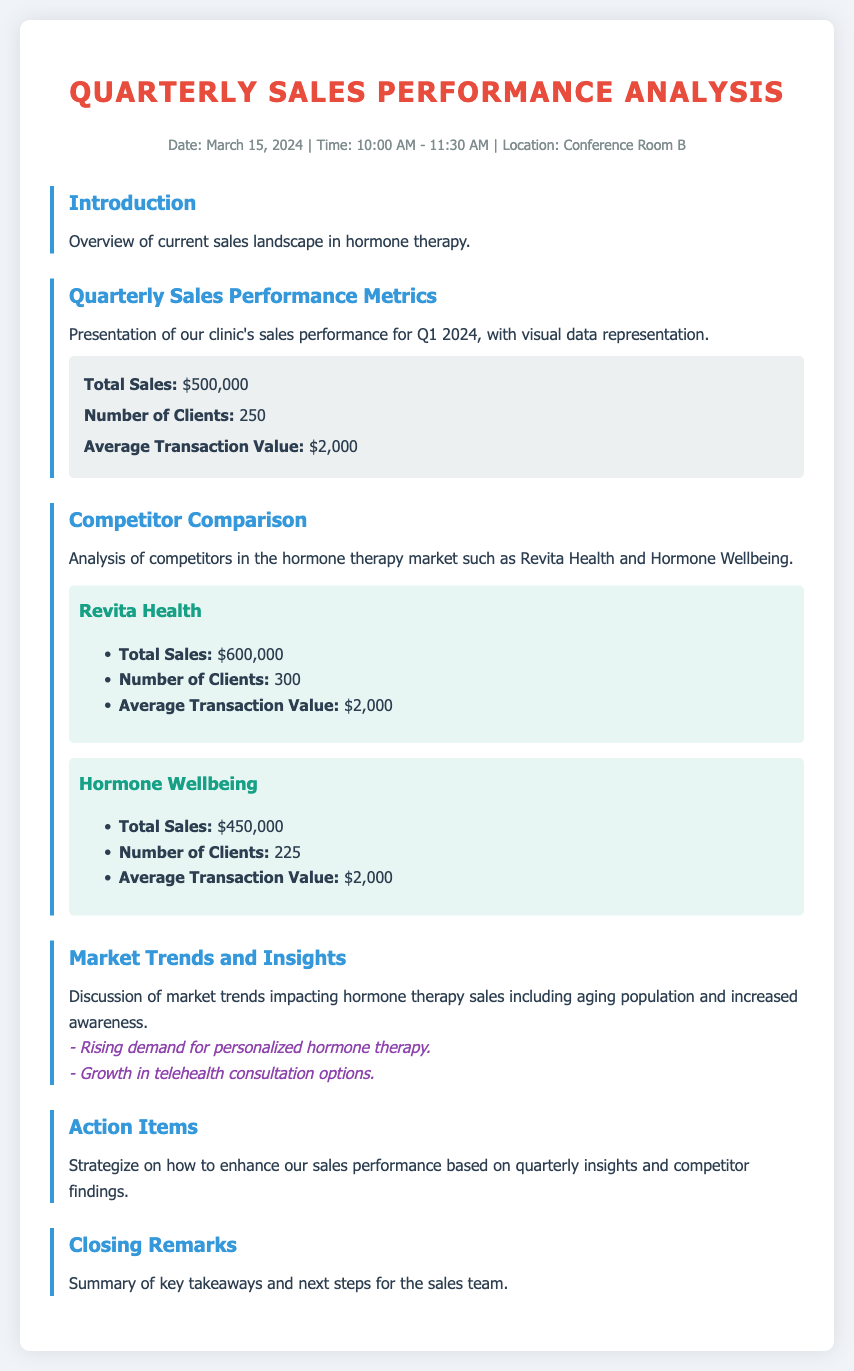What is the date of the meeting? The date of the meeting is explicitly stated in the header information section of the document.
Answer: March 15, 2024 What is the total sales figure for our clinic in Q1 2024? The total sales figure is mentioned in the Quarterly Sales Performance Metrics section of the document.
Answer: $500,000 How many clients did our clinic serve in Q1 2024? The number of clients is specified in the Quarterly Sales Performance Metrics section.
Answer: 250 What is the average transaction value for our clinic? The average transaction value is provided within the Quarterly Sales Performance Metrics section of the document.
Answer: $2,000 Which competitor has the highest total sales? The total sales of competitors are compared in the Competitor Comparison section, indicating which has the highest figure.
Answer: Revita Health What are the market trends identified in the document? The document lists some market trends in the Market Trends and Insights section as part of the discussion.
Answer: Rising demand for personalized hormone therapy What is the total number of clients served by Hormone Wellbeing? The total number of clients for Hormone Wellbeing is provided in the Competitor Comparison section of the document.
Answer: 225 What action items are discussed in the agenda? The document highlights a section dedicated to strategizing on sales performance, which contains action items.
Answer: Enhance sales performance What time is the meeting scheduled to start? The time for the meeting is found in the header information section of the document.
Answer: 10:00 AM 